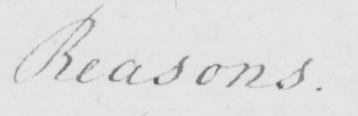What text is written in this handwritten line? Reasons . 